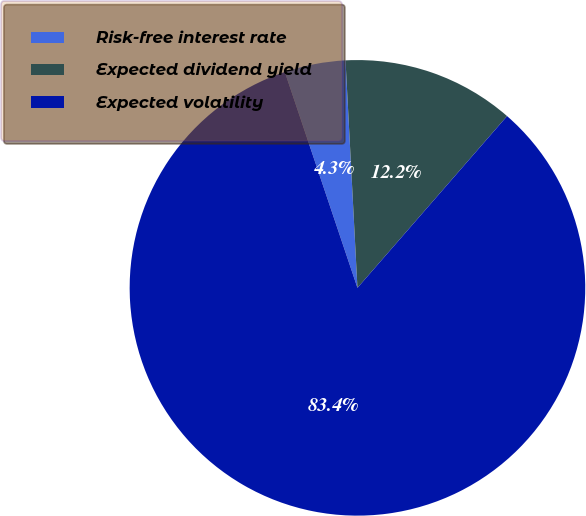Convert chart. <chart><loc_0><loc_0><loc_500><loc_500><pie_chart><fcel>Risk-free interest rate<fcel>Expected dividend yield<fcel>Expected volatility<nl><fcel>4.33%<fcel>12.24%<fcel>83.43%<nl></chart> 